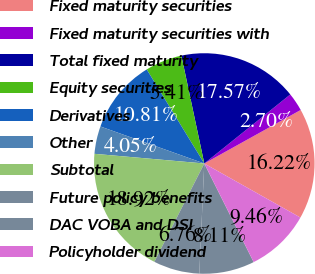Convert chart. <chart><loc_0><loc_0><loc_500><loc_500><pie_chart><fcel>Fixed maturity securities<fcel>Fixed maturity securities with<fcel>Total fixed maturity<fcel>Equity securities<fcel>Derivatives<fcel>Other<fcel>Subtotal<fcel>Future policy benefits<fcel>DAC VOBA and DSI<fcel>Policyholder dividend<nl><fcel>16.22%<fcel>2.7%<fcel>17.57%<fcel>5.41%<fcel>10.81%<fcel>4.05%<fcel>18.92%<fcel>6.76%<fcel>8.11%<fcel>9.46%<nl></chart> 